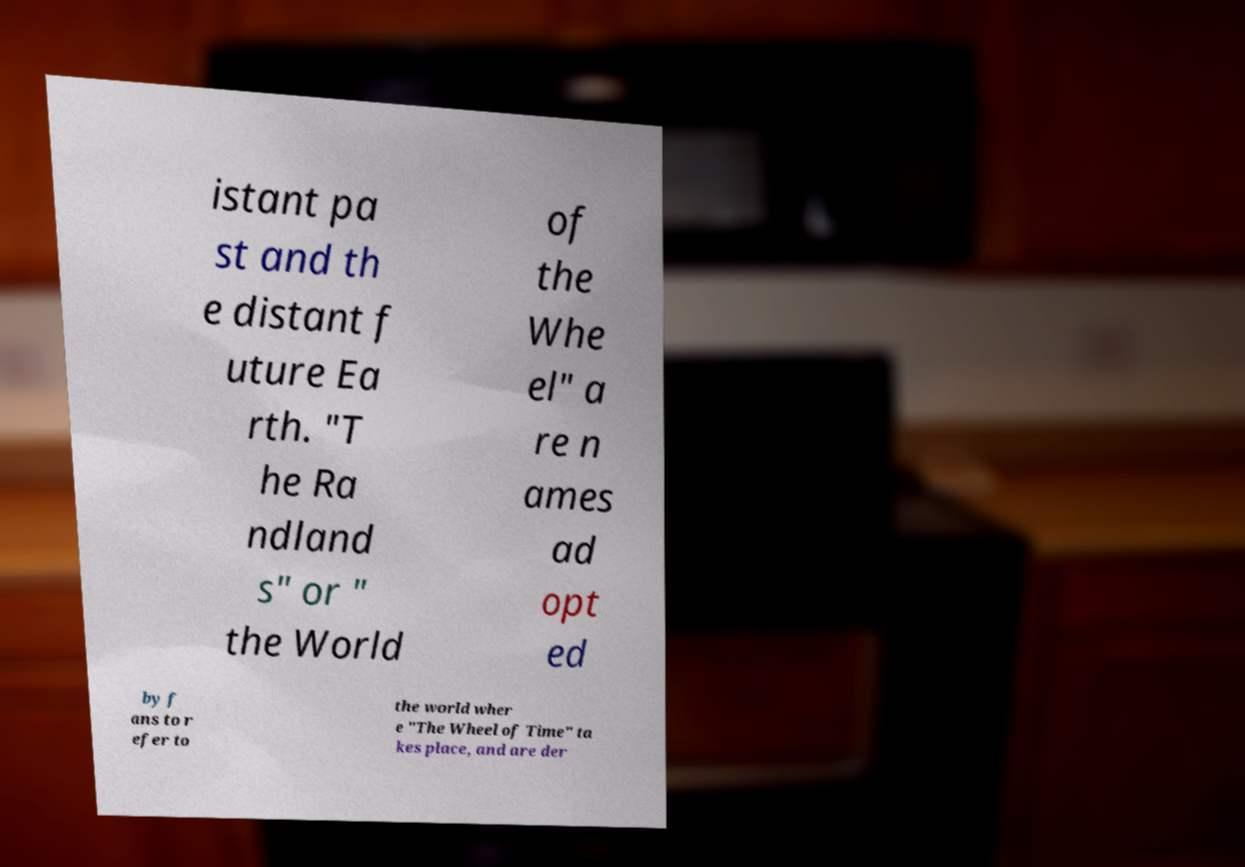What messages or text are displayed in this image? I need them in a readable, typed format. istant pa st and th e distant f uture Ea rth. "T he Ra ndland s" or " the World of the Whe el" a re n ames ad opt ed by f ans to r efer to the world wher e "The Wheel of Time" ta kes place, and are der 